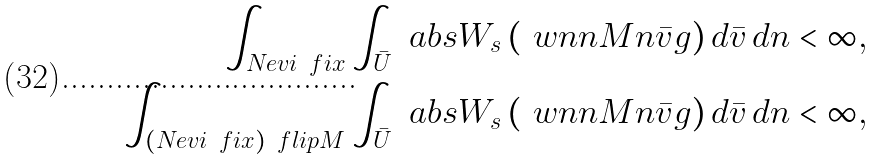<formula> <loc_0><loc_0><loc_500><loc_500>\int _ { N _ { \L } e v i ^ { \ } f i x } \int _ { \bar { U } } \ a b s { W _ { s } \left ( \ w n n M n \bar { v } g \right ) } \, d \bar { v } \, d n < \infty , \\ \int _ { ( N _ { \L } e v i ^ { \ } f i x ) ^ { \ } f l i p M } \int _ { \bar { U } } \ a b s { W _ { s } \left ( \ w n n M n \bar { v } g \right ) } \, d \bar { v } \, d n < \infty ,</formula> 